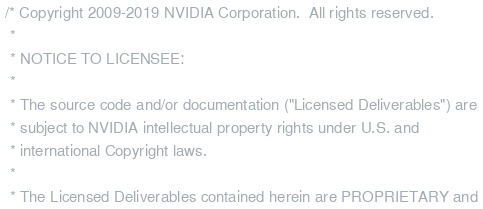Convert code to text. <code><loc_0><loc_0><loc_500><loc_500><_C_> /* Copyright 2009-2019 NVIDIA Corporation.  All rights reserved. 
  * 
  * NOTICE TO LICENSEE: 
  * 
  * The source code and/or documentation ("Licensed Deliverables") are 
  * subject to NVIDIA intellectual property rights under U.S. and 
  * international Copyright laws. 
  * 
  * The Licensed Deliverables contained herein are PROPRIETARY and </code> 